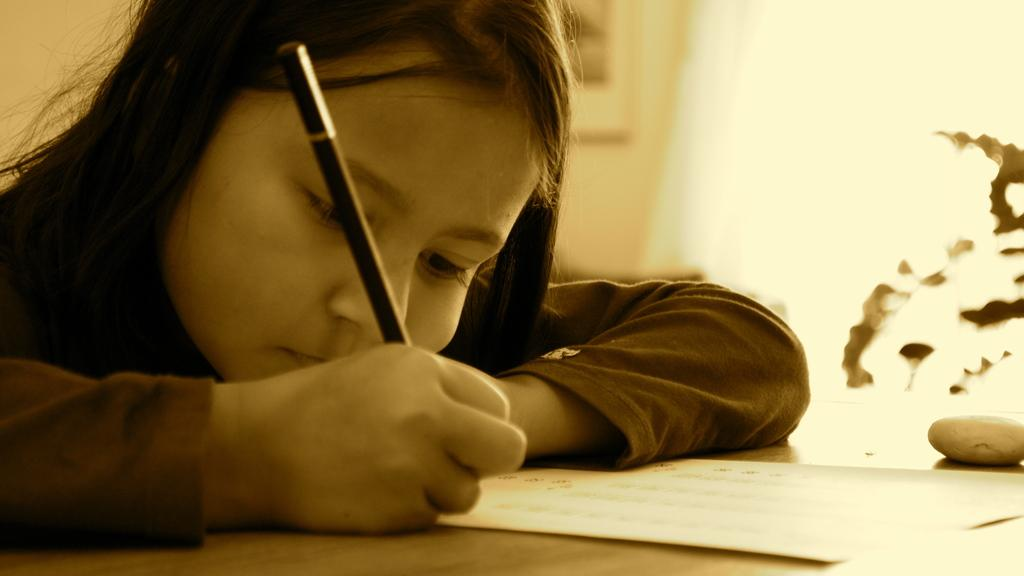Who is the main subject in the image? There is a girl in the image. What is the girl holding in the image? The girl is holding a pencil. What is the girl doing with the pencil? The girl is writing on a paper. Where is the paper located? The paper is on a table. What can be seen in the background of the image? There is a wall in the background of the image, and a photo frame is on the wall. There is also a plant in the background. What type of tank can be seen in the image? There is no tank present in the image. What causes the shock in the image? There is no shock depicted in the image. Can you describe the girl's jump in the image? There is no jump depicted in the image. 